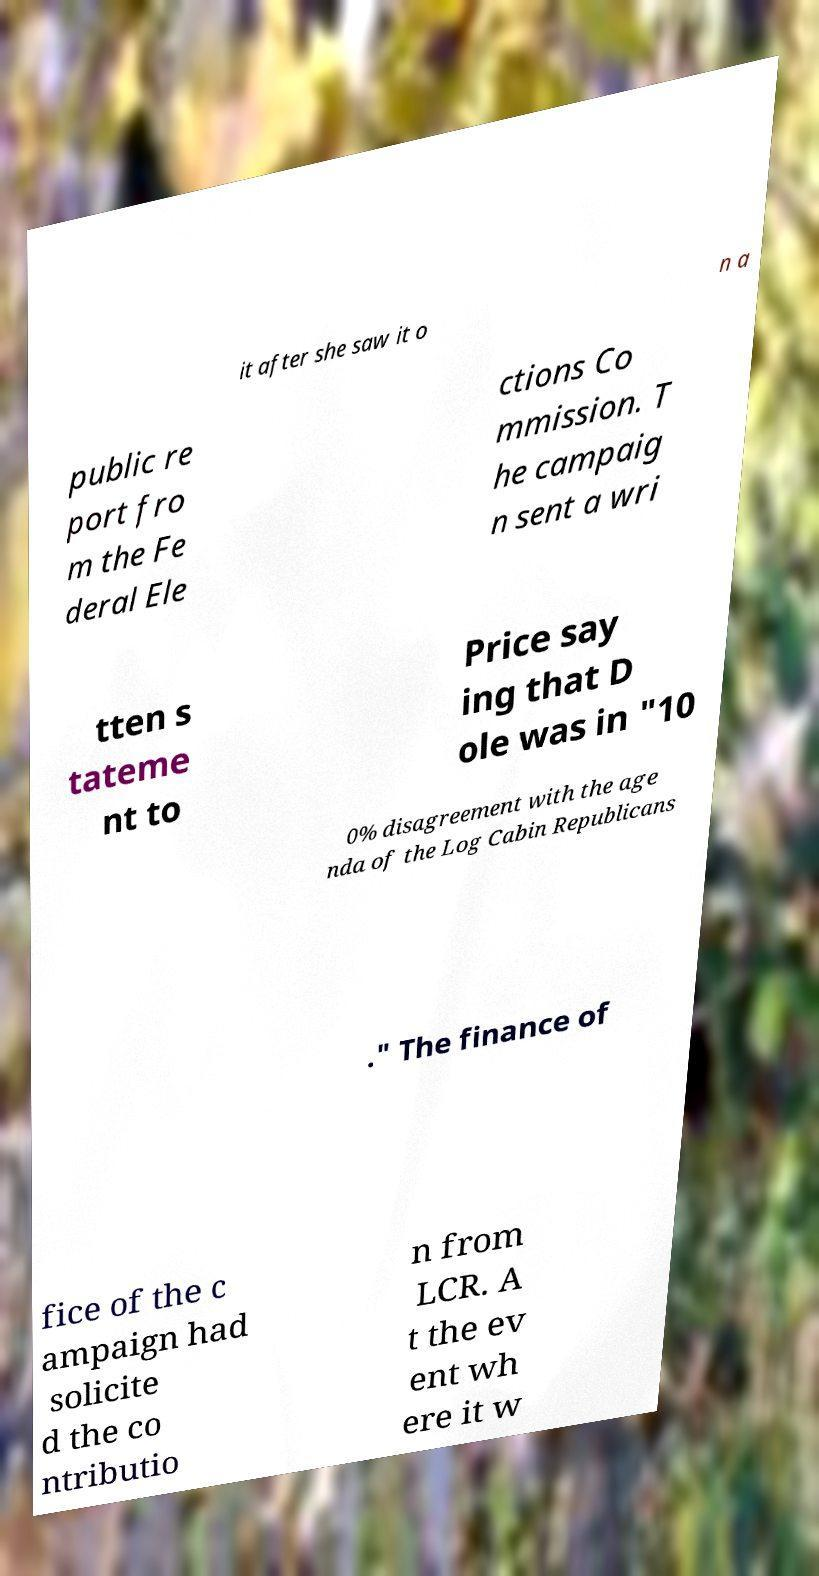What messages or text are displayed in this image? I need them in a readable, typed format. it after she saw it o n a public re port fro m the Fe deral Ele ctions Co mmission. T he campaig n sent a wri tten s tateme nt to Price say ing that D ole was in "10 0% disagreement with the age nda of the Log Cabin Republicans ." The finance of fice of the c ampaign had solicite d the co ntributio n from LCR. A t the ev ent wh ere it w 